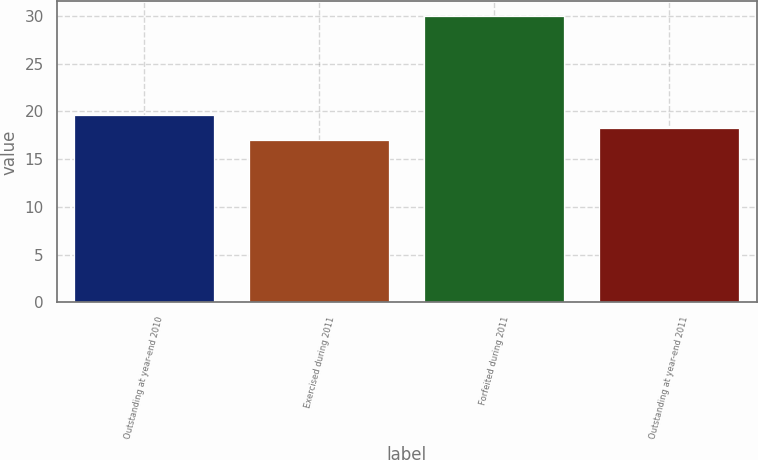Convert chart to OTSL. <chart><loc_0><loc_0><loc_500><loc_500><bar_chart><fcel>Outstanding at year-end 2010<fcel>Exercised during 2011<fcel>Forfeited during 2011<fcel>Outstanding at year-end 2011<nl><fcel>19.6<fcel>17<fcel>30<fcel>18.3<nl></chart> 